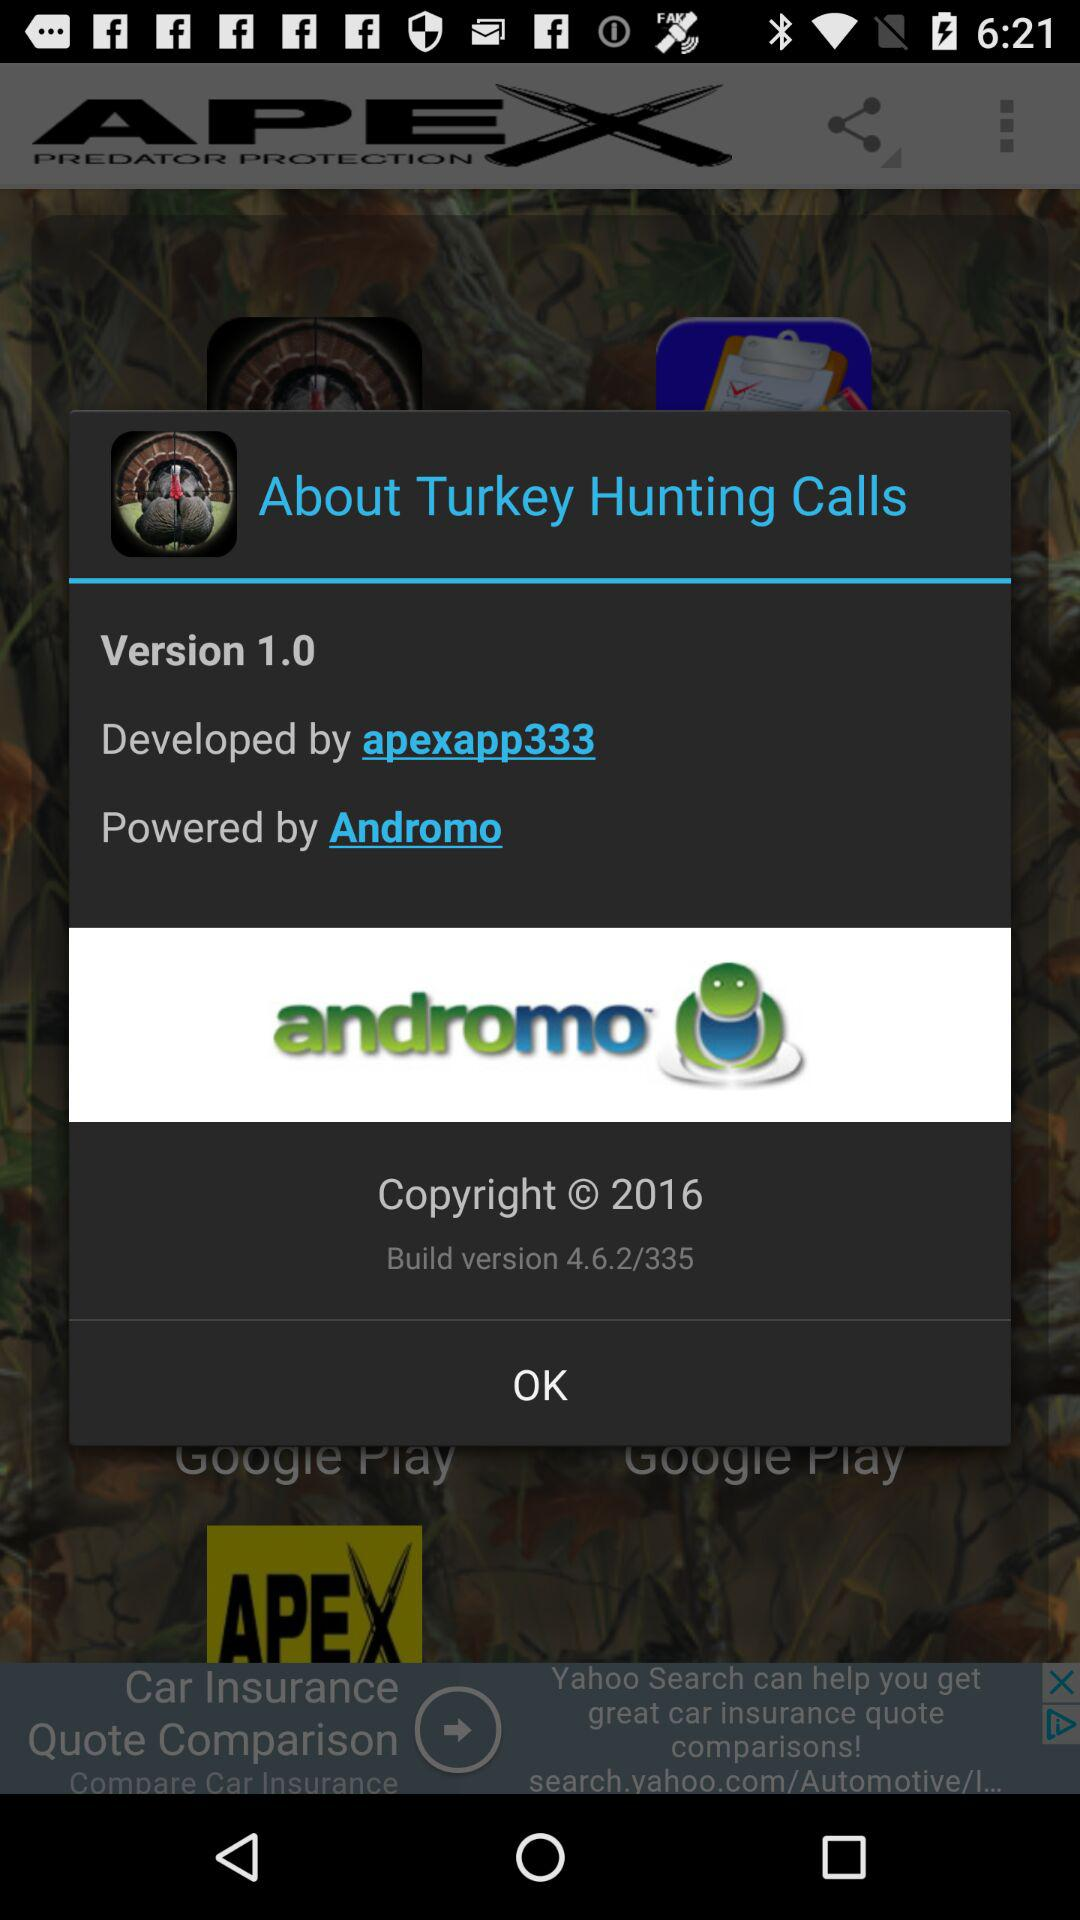Who developed the application? The application is developed by "apexapp333". 